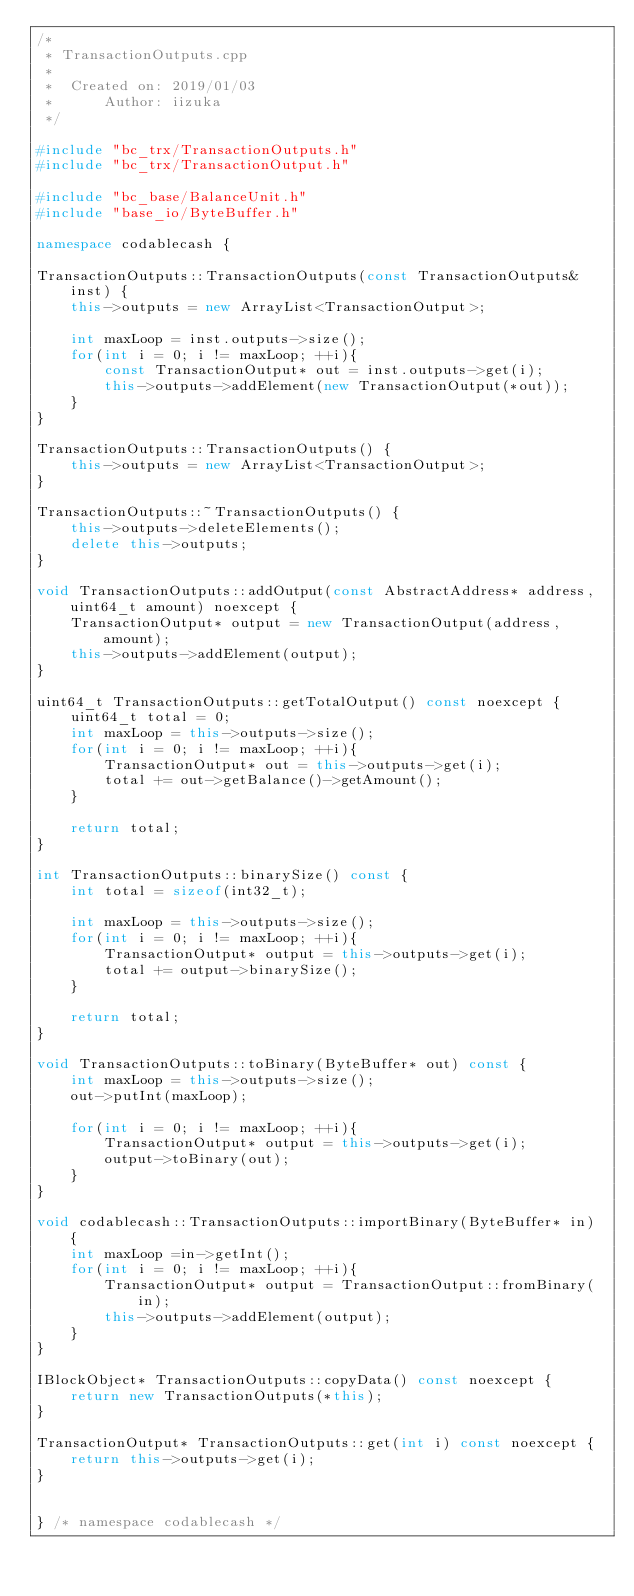<code> <loc_0><loc_0><loc_500><loc_500><_C++_>/*
 * TransactionOutputs.cpp
 *
 *  Created on: 2019/01/03
 *      Author: iizuka
 */

#include "bc_trx/TransactionOutputs.h"
#include "bc_trx/TransactionOutput.h"

#include "bc_base/BalanceUnit.h"
#include "base_io/ByteBuffer.h"

namespace codablecash {

TransactionOutputs::TransactionOutputs(const TransactionOutputs& inst) {
	this->outputs = new ArrayList<TransactionOutput>;

	int maxLoop = inst.outputs->size();
	for(int i = 0; i != maxLoop; ++i){
		const TransactionOutput* out = inst.outputs->get(i);
		this->outputs->addElement(new TransactionOutput(*out));
	}
}

TransactionOutputs::TransactionOutputs() {
	this->outputs = new ArrayList<TransactionOutput>;
}

TransactionOutputs::~TransactionOutputs() {
	this->outputs->deleteElements();
	delete this->outputs;
}

void TransactionOutputs::addOutput(const AbstractAddress* address, uint64_t amount) noexcept {
	TransactionOutput* output = new TransactionOutput(address, amount);
	this->outputs->addElement(output);
}

uint64_t TransactionOutputs::getTotalOutput() const noexcept {
	uint64_t total = 0;
	int maxLoop = this->outputs->size();
	for(int i = 0; i != maxLoop; ++i){
		TransactionOutput* out = this->outputs->get(i);
		total += out->getBalance()->getAmount();
	}

	return total;
}

int TransactionOutputs::binarySize() const {
	int total = sizeof(int32_t);

	int maxLoop = this->outputs->size();
	for(int i = 0; i != maxLoop; ++i){
		TransactionOutput* output = this->outputs->get(i);
		total += output->binarySize();
	}

	return total;
}

void TransactionOutputs::toBinary(ByteBuffer* out) const {
	int maxLoop = this->outputs->size();
	out->putInt(maxLoop);

	for(int i = 0; i != maxLoop; ++i){
		TransactionOutput* output = this->outputs->get(i);
		output->toBinary(out);
	}
}

void codablecash::TransactionOutputs::importBinary(ByteBuffer* in) {
	int maxLoop =in->getInt();
	for(int i = 0; i != maxLoop; ++i){
		TransactionOutput* output = TransactionOutput::fromBinary(in);
		this->outputs->addElement(output);
	}
}

IBlockObject* TransactionOutputs::copyData() const noexcept {
	return new TransactionOutputs(*this);
}

TransactionOutput* TransactionOutputs::get(int i) const noexcept {
	return this->outputs->get(i);
}


} /* namespace codablecash */
</code> 